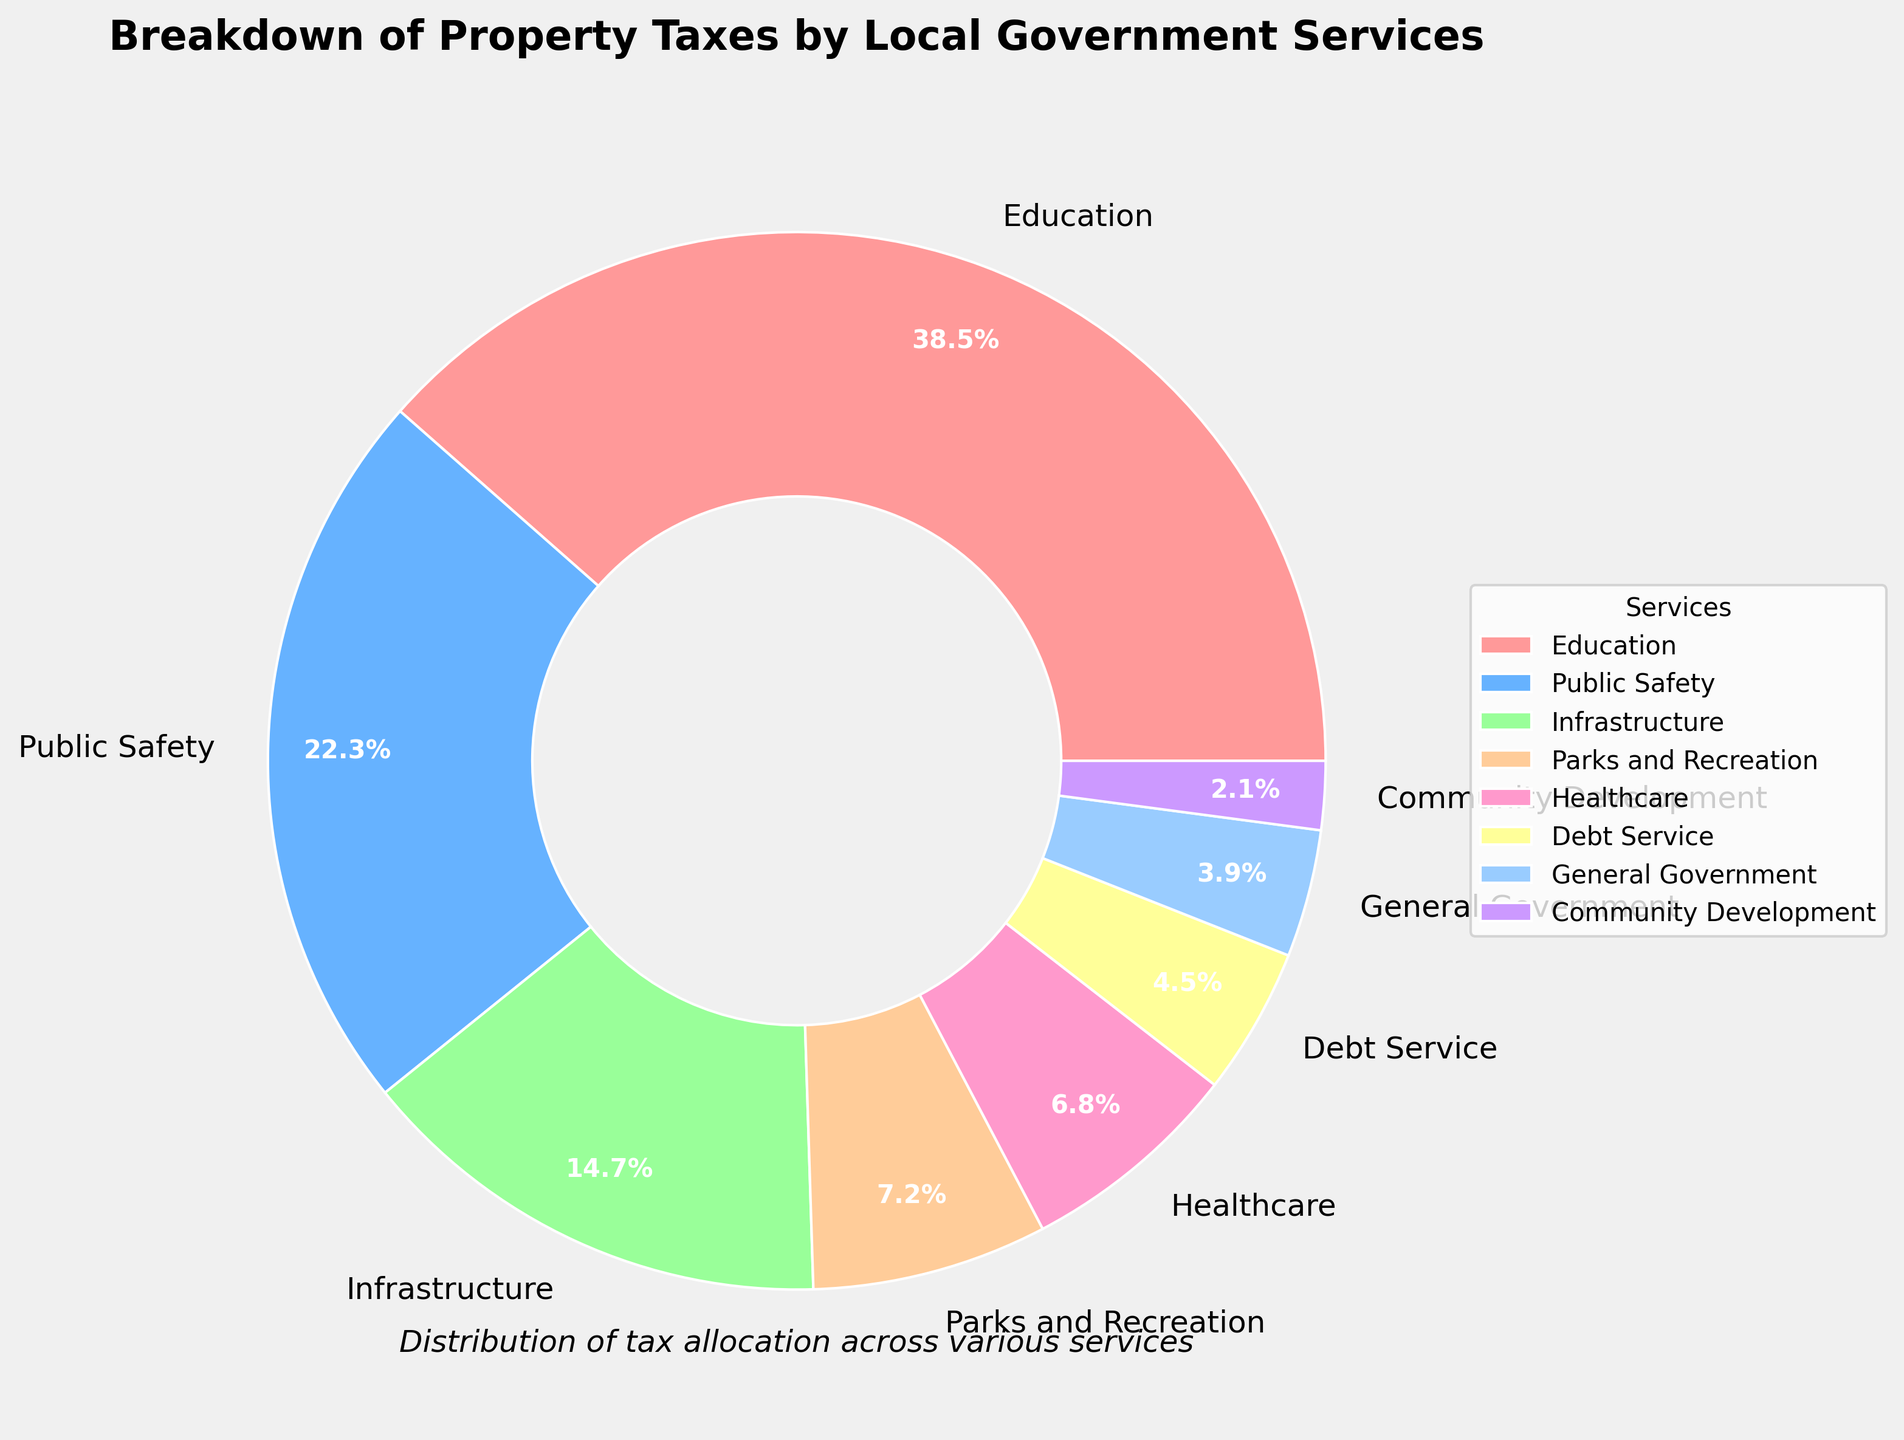Which service gets the highest percentage of property taxes? According to the pie chart, the "Education" service has the largest slice, which is labeled 38.5%. Therefore, Education receives the highest percentage of property taxes.
Answer: Education Which service receives the least amount of funding from property taxes? The pie chart shows that "Community Development" has the smallest slice, labeled at 2.1%. Therefore, it receives the least amount of property tax funding.
Answer: Community Development What percentage of property taxes is allotted to Public Safety and Infrastructure combined? From the pie chart, Public Safety receives 22.3% and Infrastructure receives 14.7%. Adding these two percentages together yields 22.3% + 14.7% = 37%.
Answer: 37% Is the percentage of property taxes allocated to Healthcare greater than that to Parks and Recreation? The pie chart shows that Healthcare receives 6.8% while Parks and Recreation receive 7.2%. Since 6.8% is less than 7.2%, Healthcare receives a smaller percentage than Parks and Recreation.
Answer: No Which service has a similar percentage allocation to Healthcare? From the pie chart, Healthcare has a percentage of 6.8%. The next closest percentage is Parks and Recreation, which is 7.2%. Both percentages are relatively close.
Answer: Parks and Recreation How much more is spent on Education compared to Debt Service in terms of property tax percentage? The pie chart indicates that Education receives 38.5% while Debt Service receives 4.5%. Subtracting these values gives 38.5% - 4.5% = 34%.
Answer: 34% What's the total percentage of property taxes spent on Healthcare, General Government, and Community Development? According to the pie chart, Healthcare is allocated 6.8%, General Government 3.9%, and Community Development 2.1%. Adding these together yields 6.8% + 3.9% + 2.1% = 12.8%.
Answer: 12.8% Which services collectively use more than half of the property taxes? From the pie chart, the percentages for Education, Public Safety, and Infrastructure need to be added. Education (38.5%), Public Safety (22.3%), and Infrastructure (14.7%) together are 38.5% + 22.3% + 14.7% = 75.5%, which is more than half (50%).
Answer: Education, Public Safety, and Infrastructure Are there more funds allocated to Parks and Recreation or Debt Service? The pie chart illustrates that Parks and Recreation receive 7.2%, while Debt Service receives 4.5%. Comparing these, Parks and Recreation receives more funds.
Answer: Parks and Recreation What is the average percentage of property taxes allocated to Education, Public Safety, and Infrastructure? The pie chart shows Education at 38.5%, Public Safety at 22.3%, and Infrastructure at 14.7%. Adding these gives 38.5% + 22.3% + 14.7% = 75.5%. Dividing by the number of services (3) gives 75.5% / 3 = 25.17%.
Answer: 25.17% 